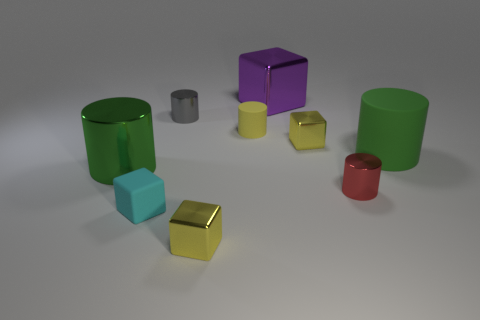Subtract 1 cylinders. How many cylinders are left? 4 Subtract all red cylinders. How many cylinders are left? 4 Subtract all large green metal cylinders. How many cylinders are left? 4 Subtract all purple cylinders. Subtract all purple balls. How many cylinders are left? 5 Add 1 large cylinders. How many objects exist? 10 Subtract all cylinders. How many objects are left? 4 Add 5 small red objects. How many small red objects are left? 6 Add 6 rubber cubes. How many rubber cubes exist? 7 Subtract 1 yellow cylinders. How many objects are left? 8 Subtract all tiny yellow metallic cubes. Subtract all large purple shiny things. How many objects are left? 6 